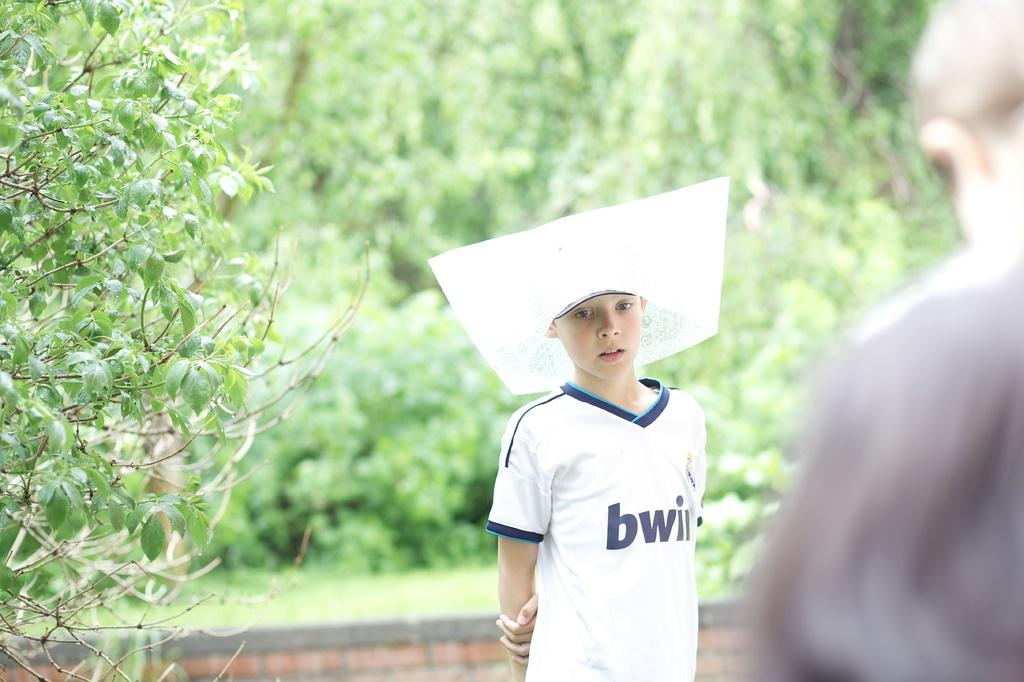<image>
Render a clear and concise summary of the photo. A boy in a white soccer jersey sponsored by bwi. 